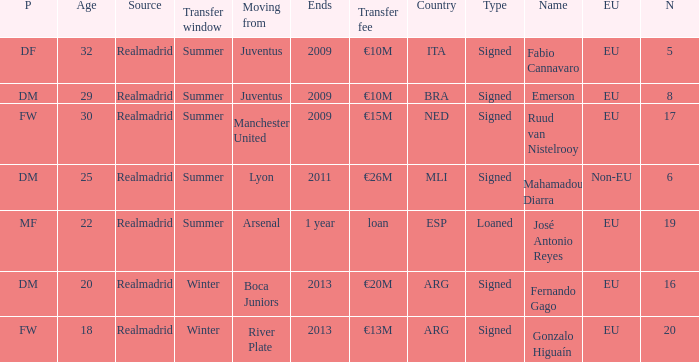What is the EU status of ESP? EU. 